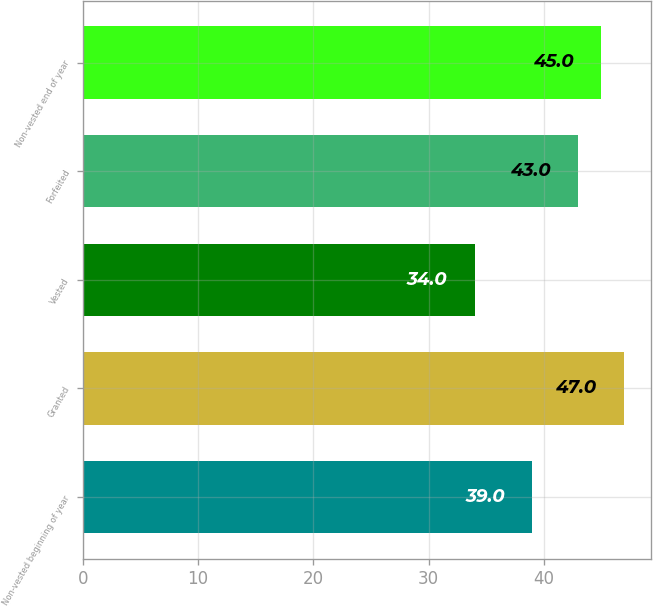Convert chart. <chart><loc_0><loc_0><loc_500><loc_500><bar_chart><fcel>Non-vested beginning of year<fcel>Granted<fcel>Vested<fcel>Forfeited<fcel>Non-vested end of year<nl><fcel>39<fcel>47<fcel>34<fcel>43<fcel>45<nl></chart> 